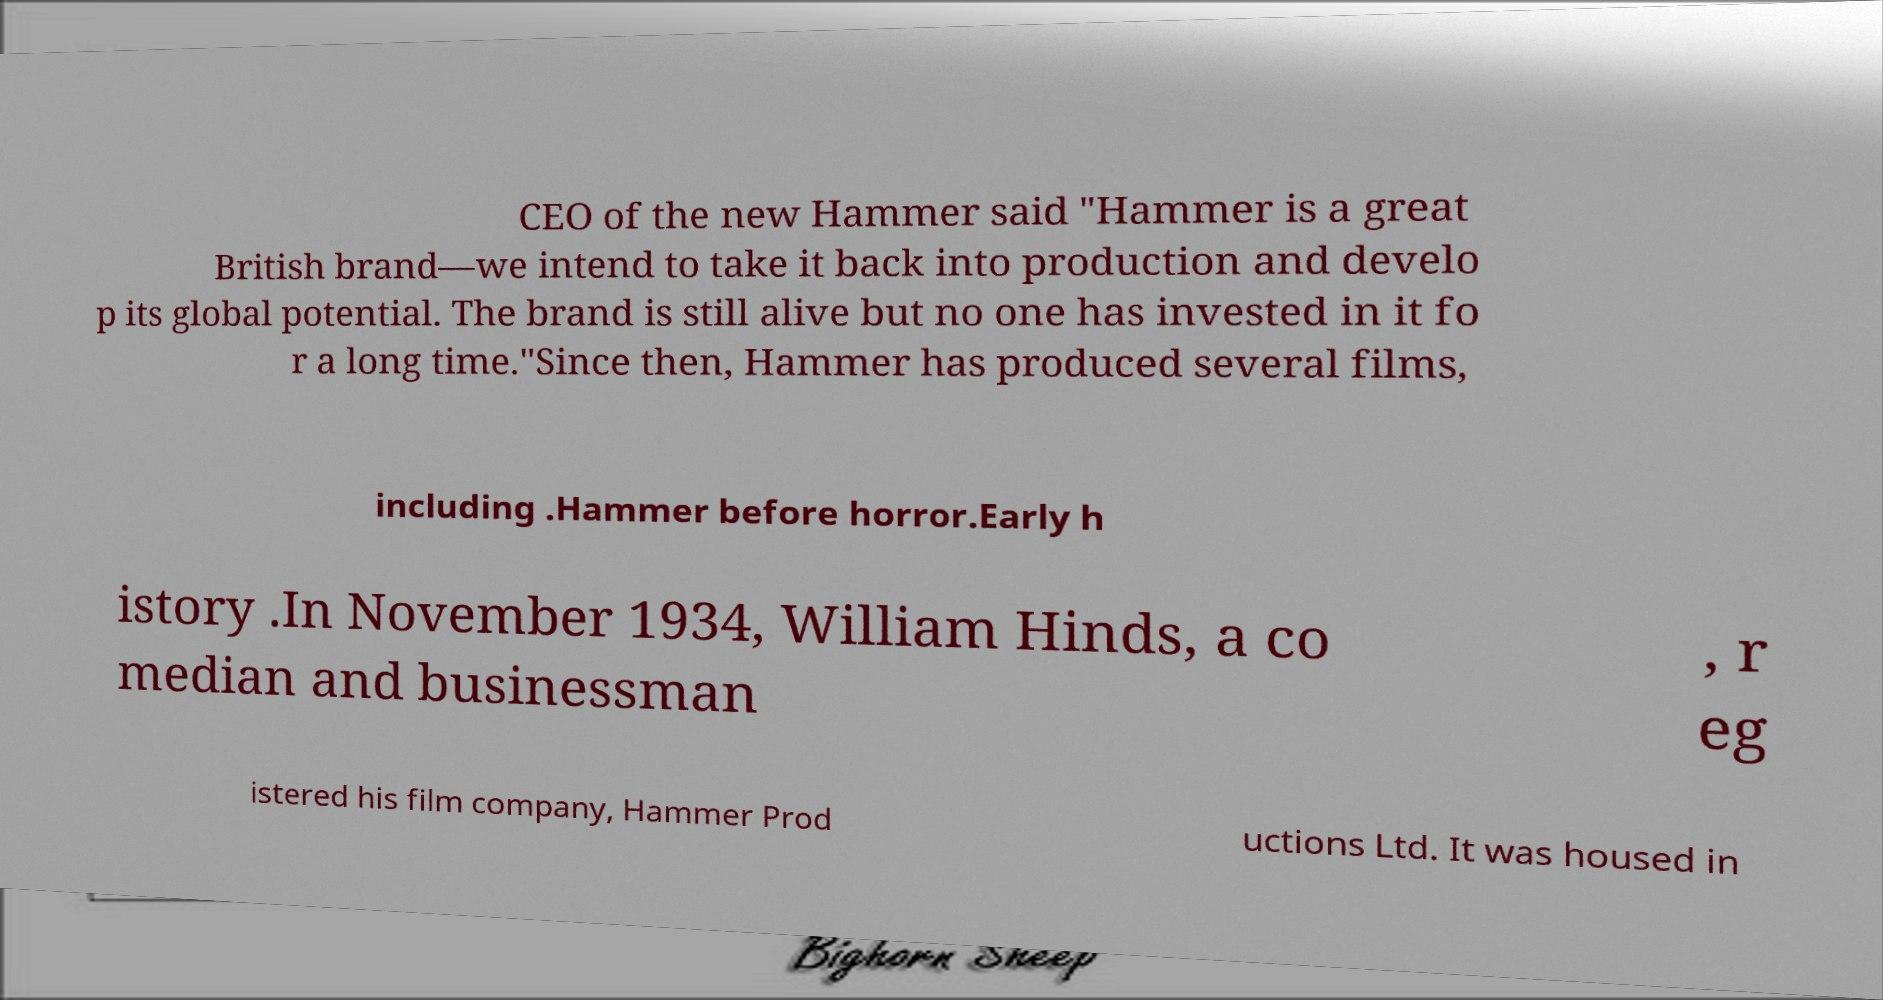What messages or text are displayed in this image? I need them in a readable, typed format. CEO of the new Hammer said "Hammer is a great British brand—we intend to take it back into production and develo p its global potential. The brand is still alive but no one has invested in it fo r a long time."Since then, Hammer has produced several films, including .Hammer before horror.Early h istory .In November 1934, William Hinds, a co median and businessman , r eg istered his film company, Hammer Prod uctions Ltd. It was housed in 